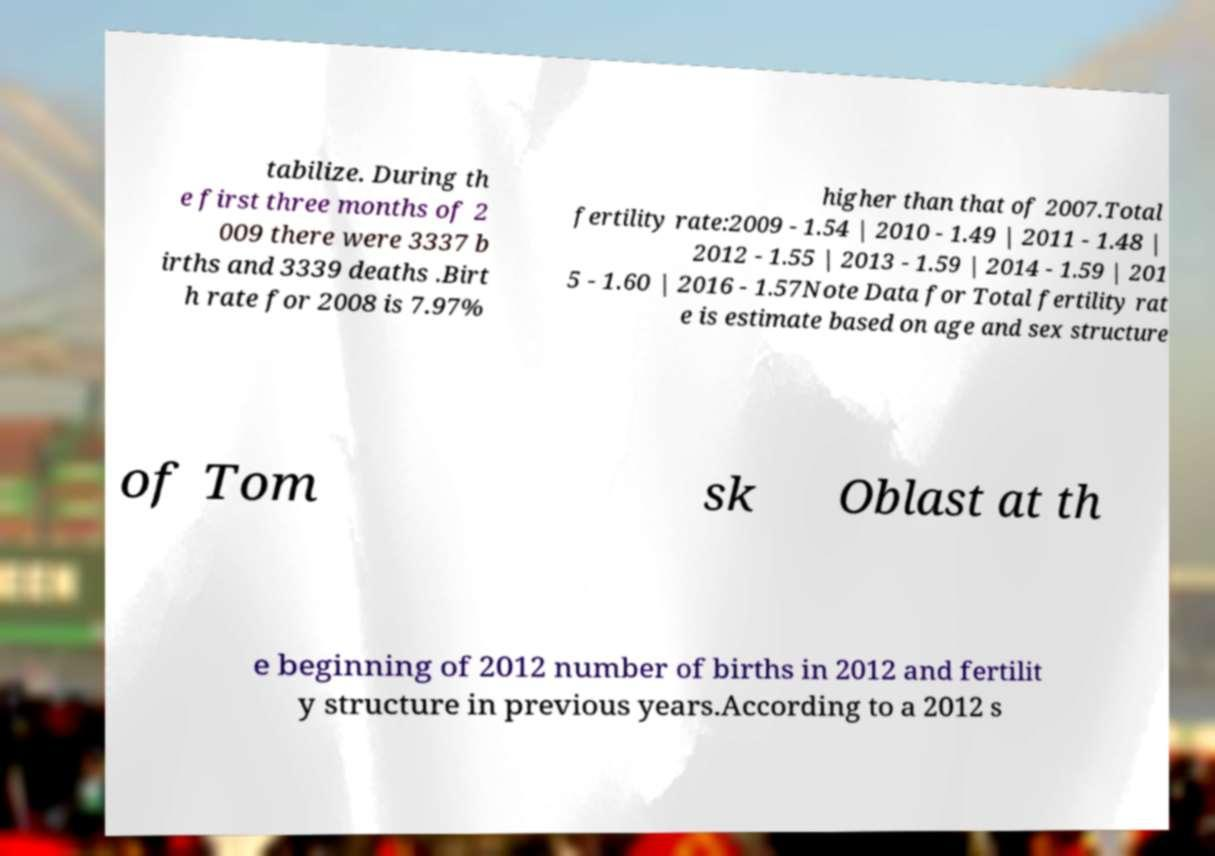I need the written content from this picture converted into text. Can you do that? tabilize. During th e first three months of 2 009 there were 3337 b irths and 3339 deaths .Birt h rate for 2008 is 7.97% higher than that of 2007.Total fertility rate:2009 - 1.54 | 2010 - 1.49 | 2011 - 1.48 | 2012 - 1.55 | 2013 - 1.59 | 2014 - 1.59 | 201 5 - 1.60 | 2016 - 1.57Note Data for Total fertility rat e is estimate based on age and sex structure of Tom sk Oblast at th e beginning of 2012 number of births in 2012 and fertilit y structure in previous years.According to a 2012 s 